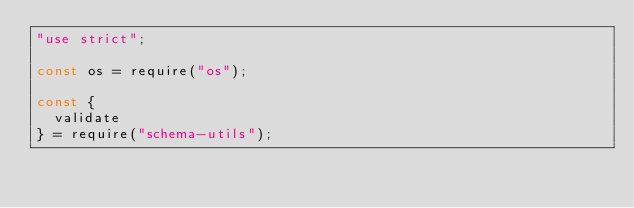<code> <loc_0><loc_0><loc_500><loc_500><_JavaScript_>"use strict";

const os = require("os");

const {
  validate
} = require("schema-utils");
</code> 